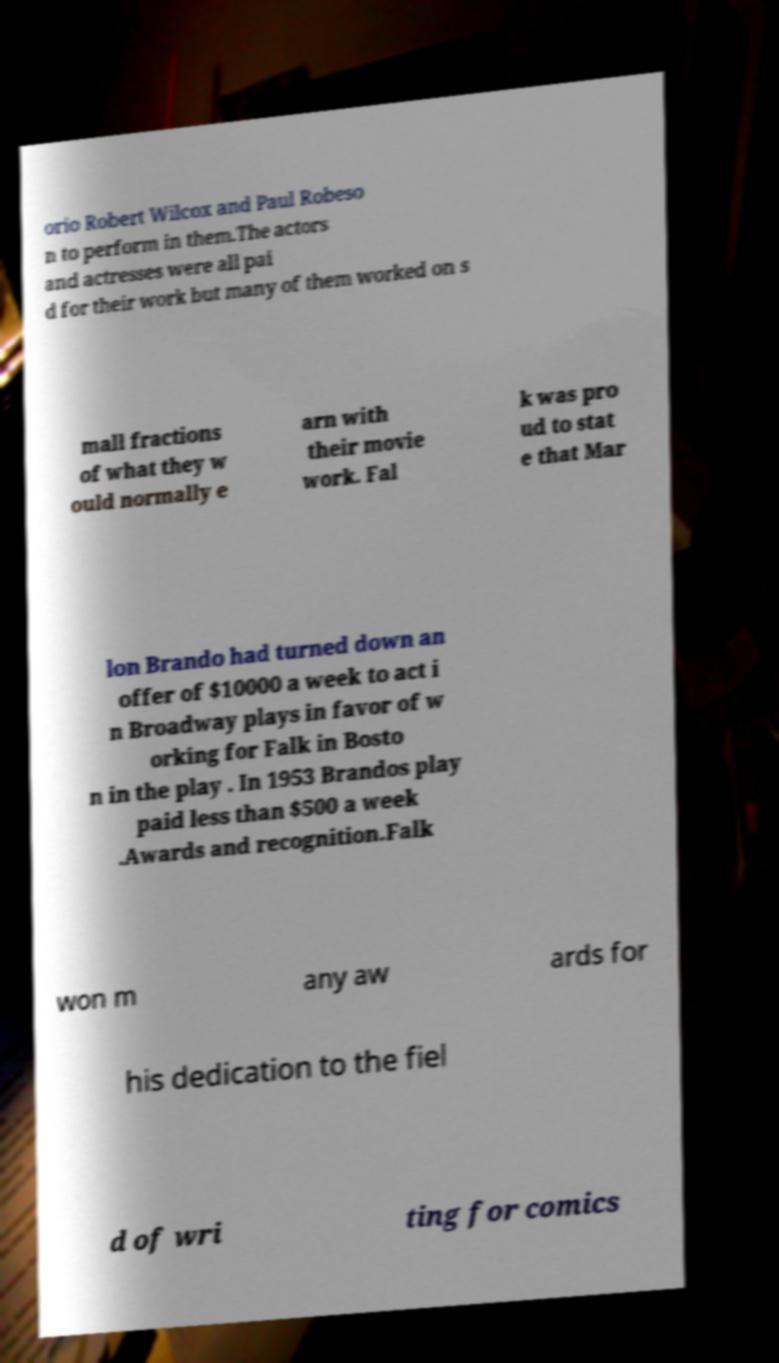Please read and relay the text visible in this image. What does it say? orio Robert Wilcox and Paul Robeso n to perform in them.The actors and actresses were all pai d for their work but many of them worked on s mall fractions of what they w ould normally e arn with their movie work. Fal k was pro ud to stat e that Mar lon Brando had turned down an offer of $10000 a week to act i n Broadway plays in favor of w orking for Falk in Bosto n in the play . In 1953 Brandos play paid less than $500 a week .Awards and recognition.Falk won m any aw ards for his dedication to the fiel d of wri ting for comics 